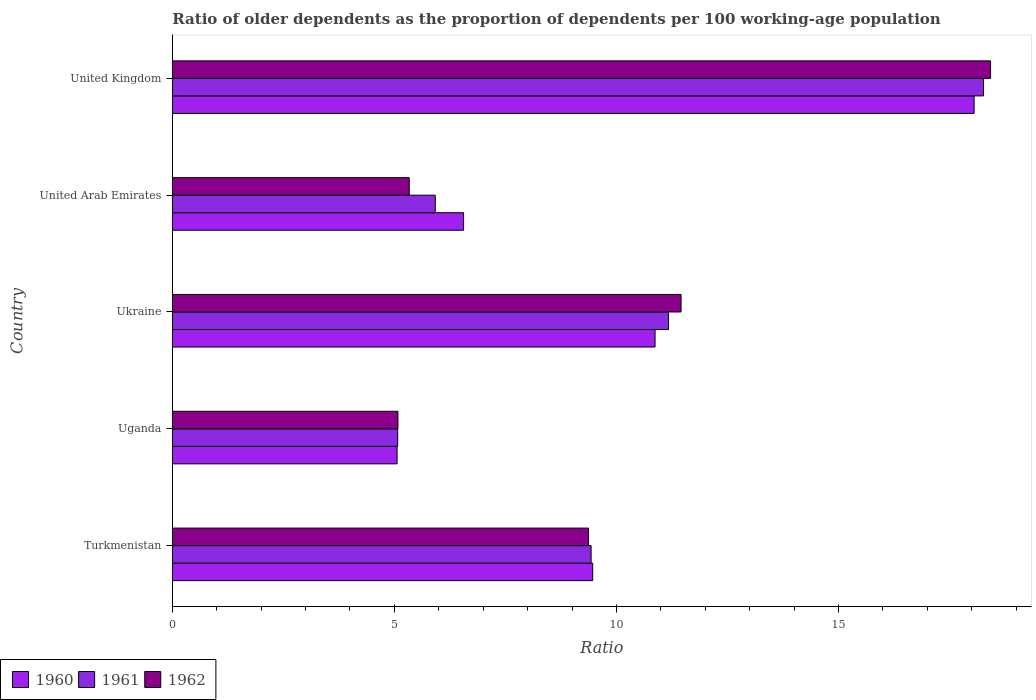How many different coloured bars are there?
Your answer should be very brief. 3. Are the number of bars per tick equal to the number of legend labels?
Ensure brevity in your answer.  Yes. Are the number of bars on each tick of the Y-axis equal?
Give a very brief answer. Yes. What is the label of the 5th group of bars from the top?
Your answer should be compact. Turkmenistan. In how many cases, is the number of bars for a given country not equal to the number of legend labels?
Keep it short and to the point. 0. What is the age dependency ratio(old) in 1961 in Turkmenistan?
Your answer should be very brief. 9.43. Across all countries, what is the maximum age dependency ratio(old) in 1962?
Provide a short and direct response. 18.43. Across all countries, what is the minimum age dependency ratio(old) in 1961?
Give a very brief answer. 5.07. In which country was the age dependency ratio(old) in 1960 maximum?
Your response must be concise. United Kingdom. In which country was the age dependency ratio(old) in 1960 minimum?
Your answer should be very brief. Uganda. What is the total age dependency ratio(old) in 1961 in the graph?
Keep it short and to the point. 49.87. What is the difference between the age dependency ratio(old) in 1961 in Ukraine and that in United Arab Emirates?
Make the answer very short. 5.25. What is the difference between the age dependency ratio(old) in 1960 in Uganda and the age dependency ratio(old) in 1961 in Turkmenistan?
Offer a terse response. -4.37. What is the average age dependency ratio(old) in 1960 per country?
Your response must be concise. 10. What is the difference between the age dependency ratio(old) in 1962 and age dependency ratio(old) in 1960 in Ukraine?
Provide a succinct answer. 0.59. In how many countries, is the age dependency ratio(old) in 1960 greater than 10 ?
Provide a short and direct response. 2. What is the ratio of the age dependency ratio(old) in 1960 in Uganda to that in Ukraine?
Give a very brief answer. 0.47. Is the difference between the age dependency ratio(old) in 1962 in Ukraine and United Arab Emirates greater than the difference between the age dependency ratio(old) in 1960 in Ukraine and United Arab Emirates?
Provide a short and direct response. Yes. What is the difference between the highest and the second highest age dependency ratio(old) in 1962?
Your response must be concise. 6.97. What is the difference between the highest and the lowest age dependency ratio(old) in 1961?
Offer a very short reply. 13.19. What does the 3rd bar from the top in United Kingdom represents?
Ensure brevity in your answer.  1960. How many bars are there?
Your answer should be compact. 15. Are the values on the major ticks of X-axis written in scientific E-notation?
Ensure brevity in your answer.  No. Does the graph contain any zero values?
Your answer should be compact. No. What is the title of the graph?
Make the answer very short. Ratio of older dependents as the proportion of dependents per 100 working-age population. Does "1974" appear as one of the legend labels in the graph?
Provide a succinct answer. No. What is the label or title of the X-axis?
Keep it short and to the point. Ratio. What is the Ratio of 1960 in Turkmenistan?
Ensure brevity in your answer.  9.47. What is the Ratio of 1961 in Turkmenistan?
Provide a short and direct response. 9.43. What is the Ratio of 1962 in Turkmenistan?
Provide a short and direct response. 9.37. What is the Ratio in 1960 in Uganda?
Give a very brief answer. 5.06. What is the Ratio of 1961 in Uganda?
Offer a terse response. 5.07. What is the Ratio of 1962 in Uganda?
Your response must be concise. 5.08. What is the Ratio of 1960 in Ukraine?
Give a very brief answer. 10.87. What is the Ratio of 1961 in Ukraine?
Provide a short and direct response. 11.17. What is the Ratio of 1962 in Ukraine?
Provide a short and direct response. 11.46. What is the Ratio of 1960 in United Arab Emirates?
Offer a very short reply. 6.56. What is the Ratio of 1961 in United Arab Emirates?
Provide a succinct answer. 5.92. What is the Ratio in 1962 in United Arab Emirates?
Offer a very short reply. 5.33. What is the Ratio in 1960 in United Kingdom?
Make the answer very short. 18.05. What is the Ratio in 1961 in United Kingdom?
Give a very brief answer. 18.27. What is the Ratio of 1962 in United Kingdom?
Keep it short and to the point. 18.43. Across all countries, what is the maximum Ratio of 1960?
Your answer should be compact. 18.05. Across all countries, what is the maximum Ratio in 1961?
Provide a short and direct response. 18.27. Across all countries, what is the maximum Ratio of 1962?
Give a very brief answer. 18.43. Across all countries, what is the minimum Ratio of 1960?
Give a very brief answer. 5.06. Across all countries, what is the minimum Ratio in 1961?
Make the answer very short. 5.07. Across all countries, what is the minimum Ratio of 1962?
Keep it short and to the point. 5.08. What is the total Ratio of 1960 in the graph?
Make the answer very short. 50.01. What is the total Ratio of 1961 in the graph?
Provide a short and direct response. 49.87. What is the total Ratio of 1962 in the graph?
Offer a terse response. 49.67. What is the difference between the Ratio of 1960 in Turkmenistan and that in Uganda?
Make the answer very short. 4.4. What is the difference between the Ratio of 1961 in Turkmenistan and that in Uganda?
Keep it short and to the point. 4.36. What is the difference between the Ratio of 1962 in Turkmenistan and that in Uganda?
Give a very brief answer. 4.29. What is the difference between the Ratio in 1960 in Turkmenistan and that in Ukraine?
Offer a very short reply. -1.4. What is the difference between the Ratio in 1961 in Turkmenistan and that in Ukraine?
Provide a succinct answer. -1.74. What is the difference between the Ratio in 1962 in Turkmenistan and that in Ukraine?
Make the answer very short. -2.08. What is the difference between the Ratio of 1960 in Turkmenistan and that in United Arab Emirates?
Offer a very short reply. 2.91. What is the difference between the Ratio in 1961 in Turkmenistan and that in United Arab Emirates?
Offer a terse response. 3.51. What is the difference between the Ratio of 1962 in Turkmenistan and that in United Arab Emirates?
Your answer should be very brief. 4.04. What is the difference between the Ratio in 1960 in Turkmenistan and that in United Kingdom?
Give a very brief answer. -8.59. What is the difference between the Ratio of 1961 in Turkmenistan and that in United Kingdom?
Provide a succinct answer. -8.84. What is the difference between the Ratio in 1962 in Turkmenistan and that in United Kingdom?
Ensure brevity in your answer.  -9.05. What is the difference between the Ratio of 1960 in Uganda and that in Ukraine?
Offer a terse response. -5.81. What is the difference between the Ratio of 1961 in Uganda and that in Ukraine?
Offer a terse response. -6.1. What is the difference between the Ratio in 1962 in Uganda and that in Ukraine?
Your answer should be very brief. -6.38. What is the difference between the Ratio in 1960 in Uganda and that in United Arab Emirates?
Provide a short and direct response. -1.5. What is the difference between the Ratio in 1961 in Uganda and that in United Arab Emirates?
Keep it short and to the point. -0.85. What is the difference between the Ratio in 1962 in Uganda and that in United Arab Emirates?
Provide a short and direct response. -0.25. What is the difference between the Ratio of 1960 in Uganda and that in United Kingdom?
Ensure brevity in your answer.  -12.99. What is the difference between the Ratio in 1961 in Uganda and that in United Kingdom?
Offer a very short reply. -13.19. What is the difference between the Ratio in 1962 in Uganda and that in United Kingdom?
Give a very brief answer. -13.35. What is the difference between the Ratio of 1960 in Ukraine and that in United Arab Emirates?
Provide a succinct answer. 4.31. What is the difference between the Ratio in 1961 in Ukraine and that in United Arab Emirates?
Give a very brief answer. 5.25. What is the difference between the Ratio in 1962 in Ukraine and that in United Arab Emirates?
Make the answer very short. 6.12. What is the difference between the Ratio in 1960 in Ukraine and that in United Kingdom?
Provide a short and direct response. -7.18. What is the difference between the Ratio in 1961 in Ukraine and that in United Kingdom?
Provide a short and direct response. -7.09. What is the difference between the Ratio in 1962 in Ukraine and that in United Kingdom?
Keep it short and to the point. -6.97. What is the difference between the Ratio in 1960 in United Arab Emirates and that in United Kingdom?
Provide a short and direct response. -11.5. What is the difference between the Ratio in 1961 in United Arab Emirates and that in United Kingdom?
Make the answer very short. -12.35. What is the difference between the Ratio of 1962 in United Arab Emirates and that in United Kingdom?
Your response must be concise. -13.09. What is the difference between the Ratio in 1960 in Turkmenistan and the Ratio in 1961 in Uganda?
Give a very brief answer. 4.39. What is the difference between the Ratio of 1960 in Turkmenistan and the Ratio of 1962 in Uganda?
Offer a very short reply. 4.39. What is the difference between the Ratio of 1961 in Turkmenistan and the Ratio of 1962 in Uganda?
Provide a succinct answer. 4.35. What is the difference between the Ratio in 1960 in Turkmenistan and the Ratio in 1961 in Ukraine?
Make the answer very short. -1.71. What is the difference between the Ratio of 1960 in Turkmenistan and the Ratio of 1962 in Ukraine?
Give a very brief answer. -1.99. What is the difference between the Ratio of 1961 in Turkmenistan and the Ratio of 1962 in Ukraine?
Your answer should be very brief. -2.03. What is the difference between the Ratio in 1960 in Turkmenistan and the Ratio in 1961 in United Arab Emirates?
Your response must be concise. 3.54. What is the difference between the Ratio of 1960 in Turkmenistan and the Ratio of 1962 in United Arab Emirates?
Offer a very short reply. 4.13. What is the difference between the Ratio in 1961 in Turkmenistan and the Ratio in 1962 in United Arab Emirates?
Offer a terse response. 4.1. What is the difference between the Ratio of 1960 in Turkmenistan and the Ratio of 1961 in United Kingdom?
Keep it short and to the point. -8.8. What is the difference between the Ratio of 1960 in Turkmenistan and the Ratio of 1962 in United Kingdom?
Your answer should be very brief. -8.96. What is the difference between the Ratio of 1961 in Turkmenistan and the Ratio of 1962 in United Kingdom?
Your answer should be very brief. -9. What is the difference between the Ratio of 1960 in Uganda and the Ratio of 1961 in Ukraine?
Ensure brevity in your answer.  -6.11. What is the difference between the Ratio of 1960 in Uganda and the Ratio of 1962 in Ukraine?
Ensure brevity in your answer.  -6.39. What is the difference between the Ratio in 1961 in Uganda and the Ratio in 1962 in Ukraine?
Your answer should be very brief. -6.38. What is the difference between the Ratio in 1960 in Uganda and the Ratio in 1961 in United Arab Emirates?
Ensure brevity in your answer.  -0.86. What is the difference between the Ratio in 1960 in Uganda and the Ratio in 1962 in United Arab Emirates?
Ensure brevity in your answer.  -0.27. What is the difference between the Ratio in 1961 in Uganda and the Ratio in 1962 in United Arab Emirates?
Offer a terse response. -0.26. What is the difference between the Ratio in 1960 in Uganda and the Ratio in 1961 in United Kingdom?
Make the answer very short. -13.21. What is the difference between the Ratio of 1960 in Uganda and the Ratio of 1962 in United Kingdom?
Ensure brevity in your answer.  -13.36. What is the difference between the Ratio of 1961 in Uganda and the Ratio of 1962 in United Kingdom?
Provide a short and direct response. -13.35. What is the difference between the Ratio of 1960 in Ukraine and the Ratio of 1961 in United Arab Emirates?
Provide a succinct answer. 4.95. What is the difference between the Ratio in 1960 in Ukraine and the Ratio in 1962 in United Arab Emirates?
Your answer should be compact. 5.54. What is the difference between the Ratio in 1961 in Ukraine and the Ratio in 1962 in United Arab Emirates?
Your answer should be very brief. 5.84. What is the difference between the Ratio in 1960 in Ukraine and the Ratio in 1961 in United Kingdom?
Your response must be concise. -7.4. What is the difference between the Ratio in 1960 in Ukraine and the Ratio in 1962 in United Kingdom?
Keep it short and to the point. -7.56. What is the difference between the Ratio of 1961 in Ukraine and the Ratio of 1962 in United Kingdom?
Your answer should be compact. -7.25. What is the difference between the Ratio of 1960 in United Arab Emirates and the Ratio of 1961 in United Kingdom?
Your answer should be compact. -11.71. What is the difference between the Ratio in 1960 in United Arab Emirates and the Ratio in 1962 in United Kingdom?
Your answer should be compact. -11.87. What is the difference between the Ratio in 1961 in United Arab Emirates and the Ratio in 1962 in United Kingdom?
Your answer should be compact. -12.5. What is the average Ratio in 1960 per country?
Ensure brevity in your answer.  10. What is the average Ratio of 1961 per country?
Provide a short and direct response. 9.97. What is the average Ratio of 1962 per country?
Offer a very short reply. 9.93. What is the difference between the Ratio in 1960 and Ratio in 1961 in Turkmenistan?
Provide a short and direct response. 0.04. What is the difference between the Ratio in 1960 and Ratio in 1962 in Turkmenistan?
Your response must be concise. 0.09. What is the difference between the Ratio in 1961 and Ratio in 1962 in Turkmenistan?
Provide a succinct answer. 0.06. What is the difference between the Ratio of 1960 and Ratio of 1961 in Uganda?
Provide a succinct answer. -0.01. What is the difference between the Ratio in 1960 and Ratio in 1962 in Uganda?
Offer a terse response. -0.02. What is the difference between the Ratio of 1961 and Ratio of 1962 in Uganda?
Offer a very short reply. -0.01. What is the difference between the Ratio of 1960 and Ratio of 1961 in Ukraine?
Give a very brief answer. -0.3. What is the difference between the Ratio in 1960 and Ratio in 1962 in Ukraine?
Give a very brief answer. -0.59. What is the difference between the Ratio of 1961 and Ratio of 1962 in Ukraine?
Keep it short and to the point. -0.28. What is the difference between the Ratio in 1960 and Ratio in 1961 in United Arab Emirates?
Your answer should be compact. 0.64. What is the difference between the Ratio in 1960 and Ratio in 1962 in United Arab Emirates?
Provide a short and direct response. 1.22. What is the difference between the Ratio in 1961 and Ratio in 1962 in United Arab Emirates?
Your answer should be very brief. 0.59. What is the difference between the Ratio of 1960 and Ratio of 1961 in United Kingdom?
Your answer should be very brief. -0.21. What is the difference between the Ratio of 1960 and Ratio of 1962 in United Kingdom?
Provide a short and direct response. -0.37. What is the difference between the Ratio of 1961 and Ratio of 1962 in United Kingdom?
Make the answer very short. -0.16. What is the ratio of the Ratio in 1960 in Turkmenistan to that in Uganda?
Make the answer very short. 1.87. What is the ratio of the Ratio of 1961 in Turkmenistan to that in Uganda?
Ensure brevity in your answer.  1.86. What is the ratio of the Ratio of 1962 in Turkmenistan to that in Uganda?
Offer a very short reply. 1.84. What is the ratio of the Ratio in 1960 in Turkmenistan to that in Ukraine?
Your answer should be compact. 0.87. What is the ratio of the Ratio of 1961 in Turkmenistan to that in Ukraine?
Make the answer very short. 0.84. What is the ratio of the Ratio of 1962 in Turkmenistan to that in Ukraine?
Your response must be concise. 0.82. What is the ratio of the Ratio in 1960 in Turkmenistan to that in United Arab Emirates?
Your answer should be compact. 1.44. What is the ratio of the Ratio of 1961 in Turkmenistan to that in United Arab Emirates?
Provide a succinct answer. 1.59. What is the ratio of the Ratio of 1962 in Turkmenistan to that in United Arab Emirates?
Provide a succinct answer. 1.76. What is the ratio of the Ratio in 1960 in Turkmenistan to that in United Kingdom?
Give a very brief answer. 0.52. What is the ratio of the Ratio of 1961 in Turkmenistan to that in United Kingdom?
Give a very brief answer. 0.52. What is the ratio of the Ratio of 1962 in Turkmenistan to that in United Kingdom?
Make the answer very short. 0.51. What is the ratio of the Ratio of 1960 in Uganda to that in Ukraine?
Offer a very short reply. 0.47. What is the ratio of the Ratio of 1961 in Uganda to that in Ukraine?
Your answer should be compact. 0.45. What is the ratio of the Ratio in 1962 in Uganda to that in Ukraine?
Make the answer very short. 0.44. What is the ratio of the Ratio in 1960 in Uganda to that in United Arab Emirates?
Provide a short and direct response. 0.77. What is the ratio of the Ratio in 1961 in Uganda to that in United Arab Emirates?
Keep it short and to the point. 0.86. What is the ratio of the Ratio of 1962 in Uganda to that in United Arab Emirates?
Keep it short and to the point. 0.95. What is the ratio of the Ratio in 1960 in Uganda to that in United Kingdom?
Offer a very short reply. 0.28. What is the ratio of the Ratio of 1961 in Uganda to that in United Kingdom?
Your answer should be compact. 0.28. What is the ratio of the Ratio of 1962 in Uganda to that in United Kingdom?
Your response must be concise. 0.28. What is the ratio of the Ratio of 1960 in Ukraine to that in United Arab Emirates?
Your answer should be compact. 1.66. What is the ratio of the Ratio of 1961 in Ukraine to that in United Arab Emirates?
Give a very brief answer. 1.89. What is the ratio of the Ratio in 1962 in Ukraine to that in United Arab Emirates?
Ensure brevity in your answer.  2.15. What is the ratio of the Ratio in 1960 in Ukraine to that in United Kingdom?
Provide a succinct answer. 0.6. What is the ratio of the Ratio of 1961 in Ukraine to that in United Kingdom?
Provide a succinct answer. 0.61. What is the ratio of the Ratio in 1962 in Ukraine to that in United Kingdom?
Make the answer very short. 0.62. What is the ratio of the Ratio of 1960 in United Arab Emirates to that in United Kingdom?
Offer a terse response. 0.36. What is the ratio of the Ratio of 1961 in United Arab Emirates to that in United Kingdom?
Provide a short and direct response. 0.32. What is the ratio of the Ratio of 1962 in United Arab Emirates to that in United Kingdom?
Give a very brief answer. 0.29. What is the difference between the highest and the second highest Ratio of 1960?
Offer a very short reply. 7.18. What is the difference between the highest and the second highest Ratio in 1961?
Ensure brevity in your answer.  7.09. What is the difference between the highest and the second highest Ratio in 1962?
Keep it short and to the point. 6.97. What is the difference between the highest and the lowest Ratio in 1960?
Make the answer very short. 12.99. What is the difference between the highest and the lowest Ratio in 1961?
Make the answer very short. 13.19. What is the difference between the highest and the lowest Ratio in 1962?
Ensure brevity in your answer.  13.35. 